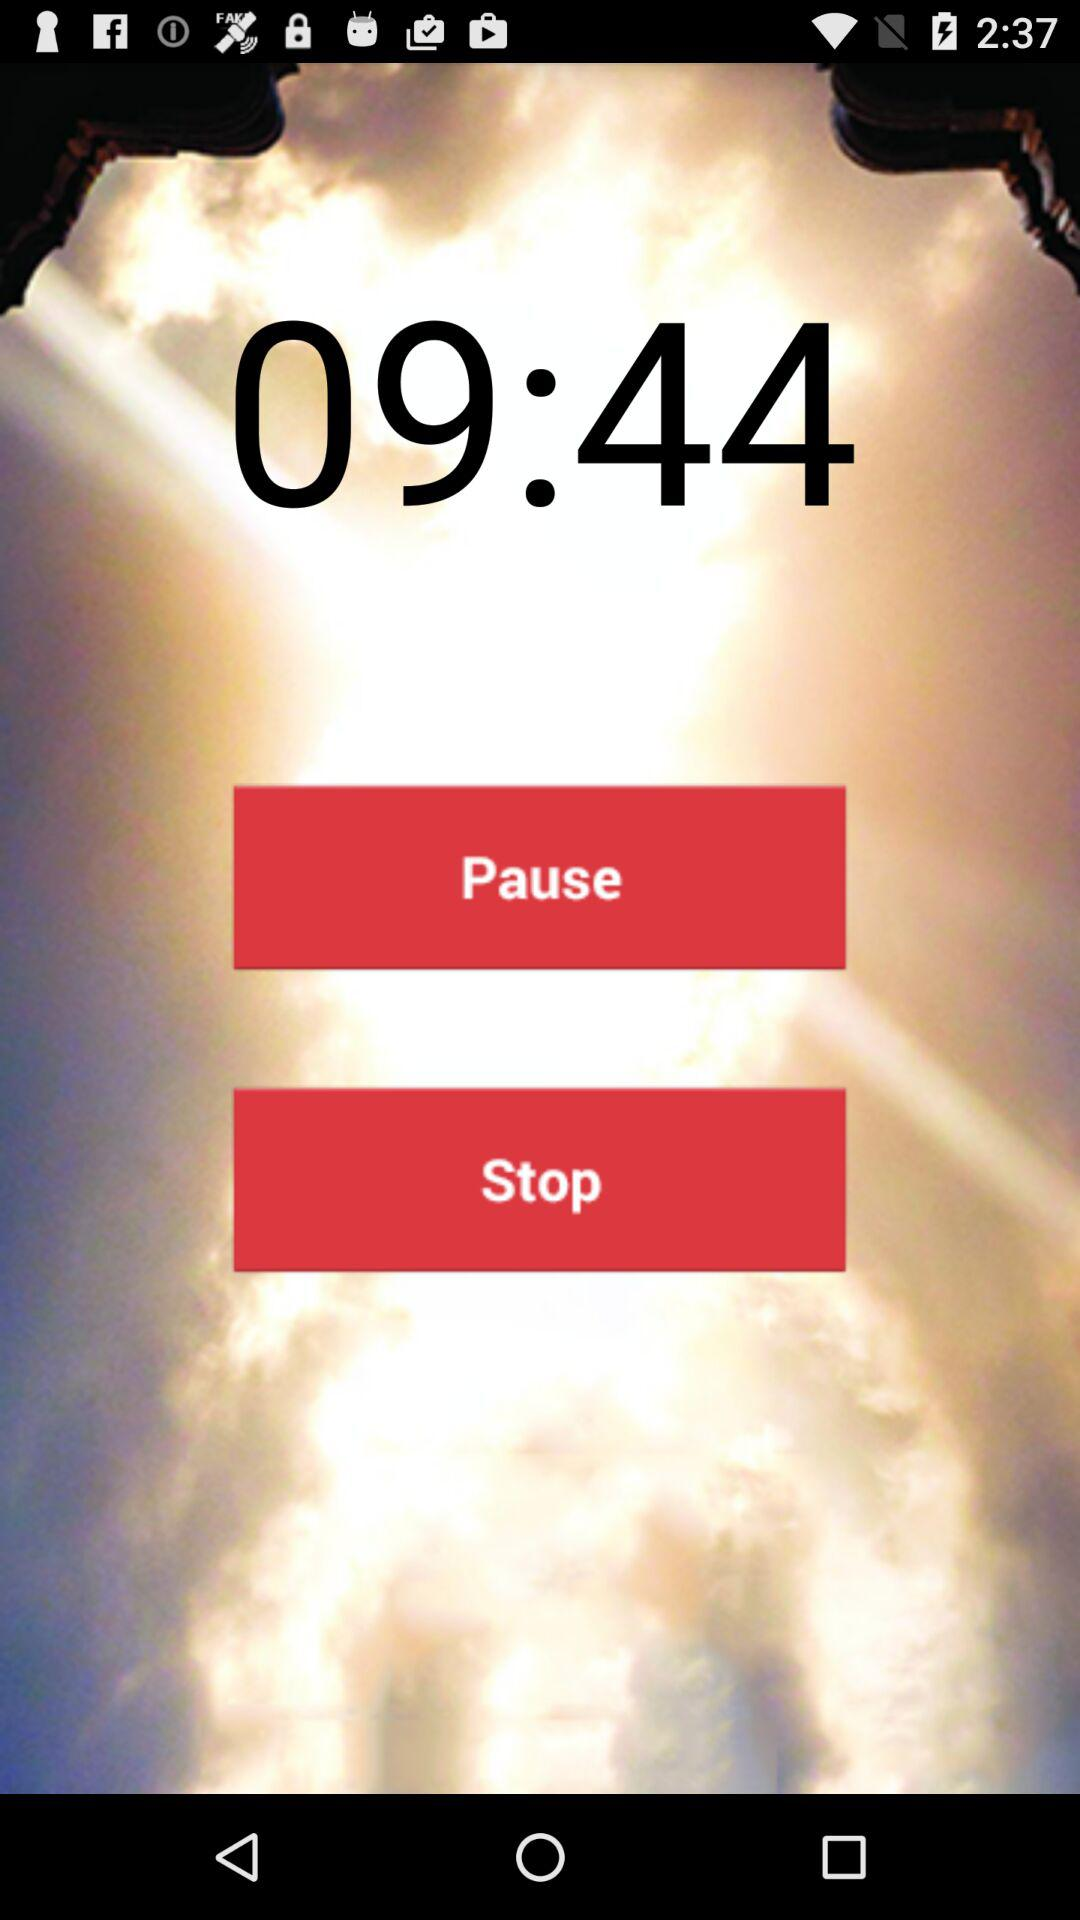What time was displayed on the screen? The time was 09:44. 